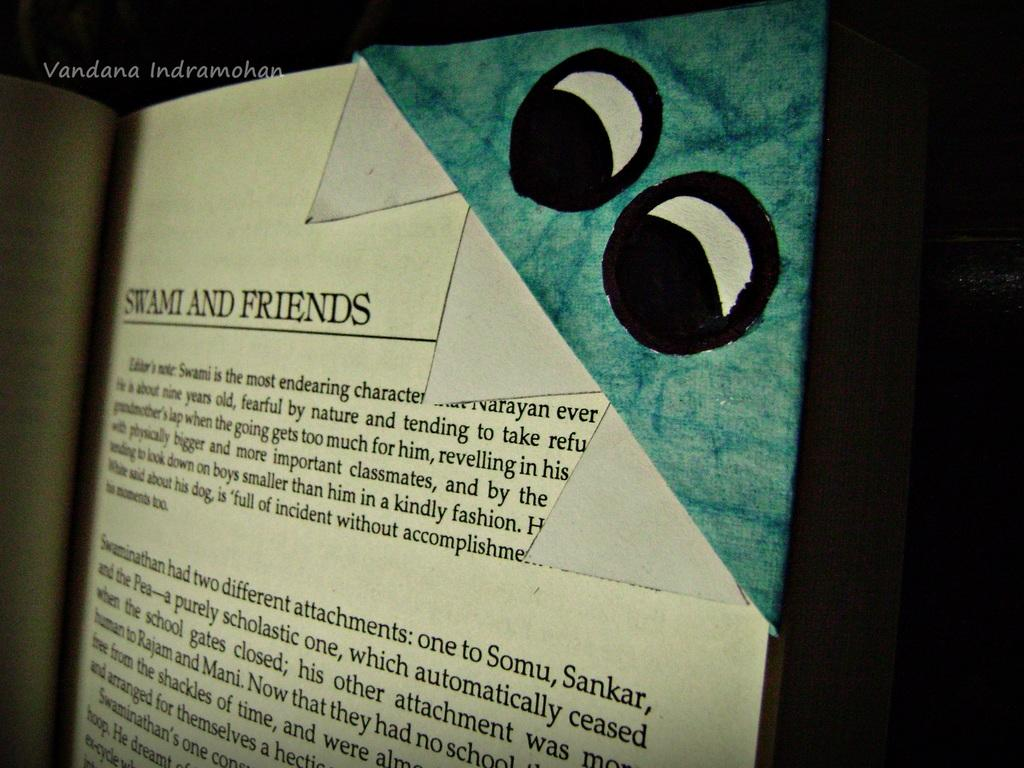<image>
Provide a brief description of the given image. A page of a book called Stami and Friends with eyes 